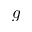Convert formula to latex. <formula><loc_0><loc_0><loc_500><loc_500>g</formula> 